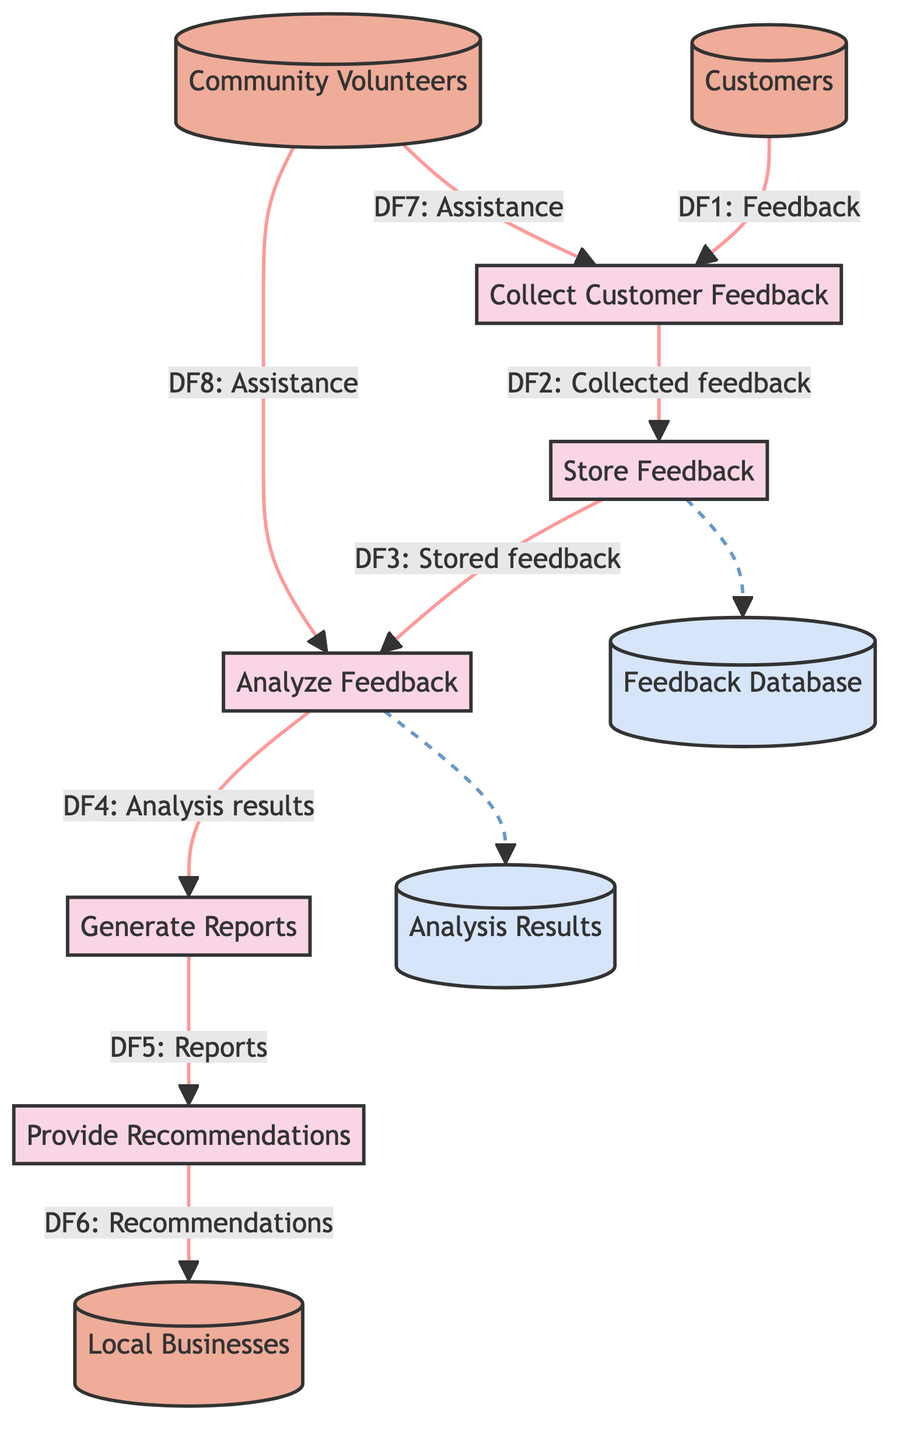What is the first process in the diagram? The first process shown is "Collect Customer Feedback", which is directly connected to the customers who provide feedback.
Answer: Collect Customer Feedback How many data stores are in the diagram? There are two data stores indicated in the diagram: the "Feedback Database" and the "Analysis Results".
Answer: 2 Who assists in the "Analyze Feedback" process? The entity labeled "Community Volunteers" assists in the "Analyze Feedback" process, as shown by the corresponding data flow.
Answer: Community Volunteers What is the output of the "Generate Reports" process? The output of the "Generate Reports" process is directed into the "Provide Recommendations" process, indicating reports are utilized for generating recommendations.
Answer: Reports What is the relationship between the "Store Feedback" and "Analyze Feedback" processes? The "Store Feedback" process sends stored feedback to the "Analyze Feedback" process, showing a direct flow of data between the two processes.
Answer: Stored feedback Which entity provides feedback to the system? The entity providing feedback to the system is "Customers", as they are the source of the input in the diagram.
Answer: Customers What is the flow number associated with the data moving from "Analyze Feedback" to "Generate Reports"? The flow number for the data moving from "Analyze Feedback" to "Generate Reports" is "DF4".
Answer: DF4 What type of diagram is represented? The type of diagram represented is a Data Flow Diagram, which illustrates processes, data stores, inputs, and outputs.
Answer: Data Flow Diagram 